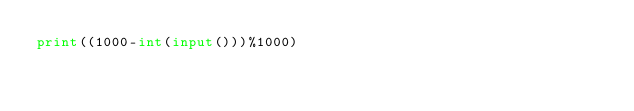Convert code to text. <code><loc_0><loc_0><loc_500><loc_500><_Python_>print((1000-int(input()))%1000)</code> 